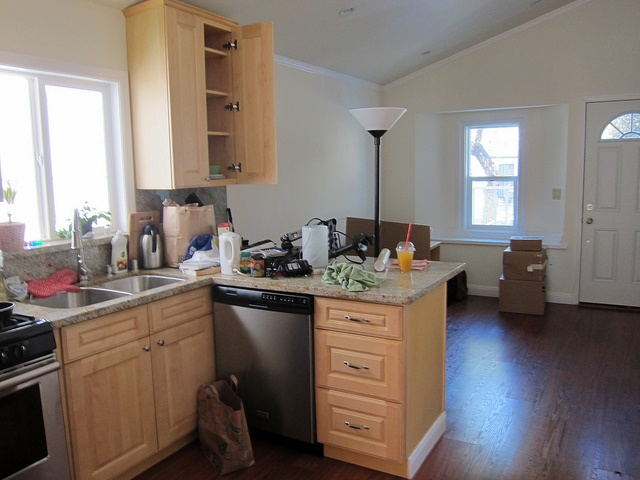Describe the objects in this image and their specific colors. I can see oven in darkgray, black, gray, and maroon tones, sink in darkgray, gray, and black tones, sink in darkgray and gray tones, potted plant in darkgray, white, gray, and beige tones, and potted plant in darkgray, white, and gray tones in this image. 